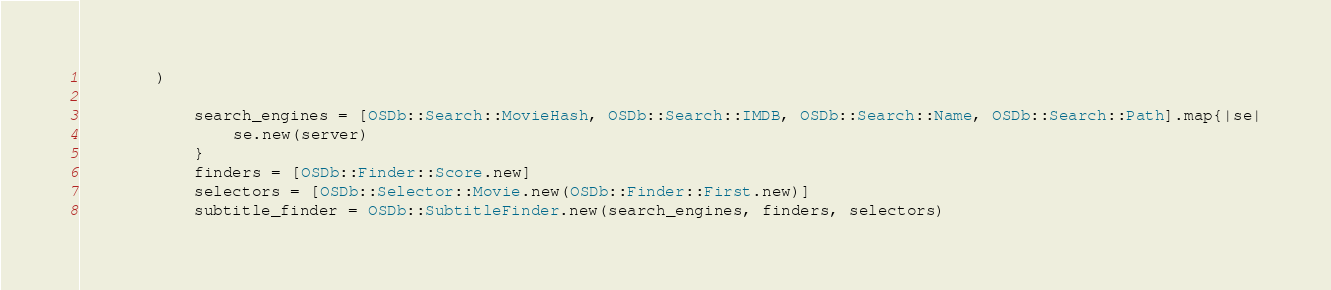<code> <loc_0><loc_0><loc_500><loc_500><_Ruby_>	    ) 

			search_engines = [OSDb::Search::MovieHash, OSDb::Search::IMDB, OSDb::Search::Name, OSDb::Search::Path].map{|se|
				se.new(server)
			}
			finders = [OSDb::Finder::Score.new]
			selectors = [OSDb::Selector::Movie.new(OSDb::Finder::First.new)]
			subtitle_finder = OSDb::SubtitleFinder.new(search_engines, finders, selectors)</code> 